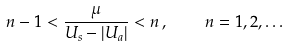<formula> <loc_0><loc_0><loc_500><loc_500>n - 1 < \frac { \mu } { U _ { s } - | U _ { a } | } < n \, , \quad n = 1 , 2 , \dots</formula> 